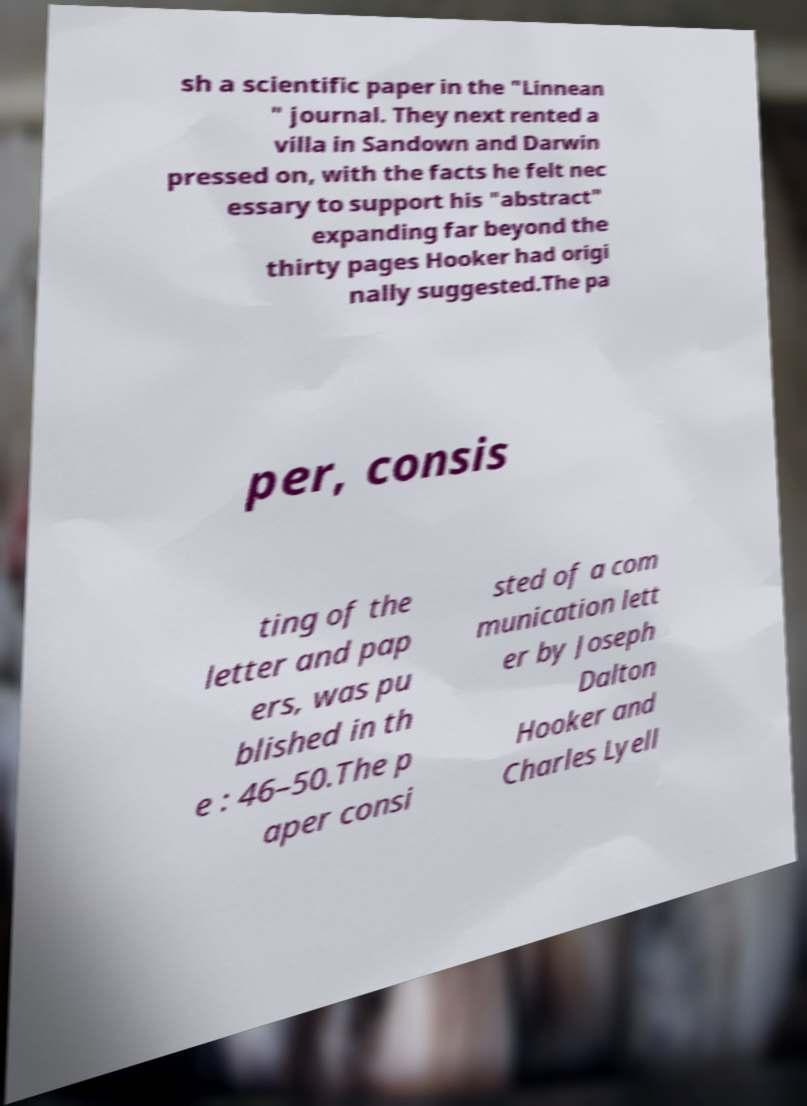Please identify and transcribe the text found in this image. sh a scientific paper in the "Linnean " journal. They next rented a villa in Sandown and Darwin pressed on, with the facts he felt nec essary to support his "abstract" expanding far beyond the thirty pages Hooker had origi nally suggested.The pa per, consis ting of the letter and pap ers, was pu blished in th e : 46–50.The p aper consi sted of a com munication lett er by Joseph Dalton Hooker and Charles Lyell 